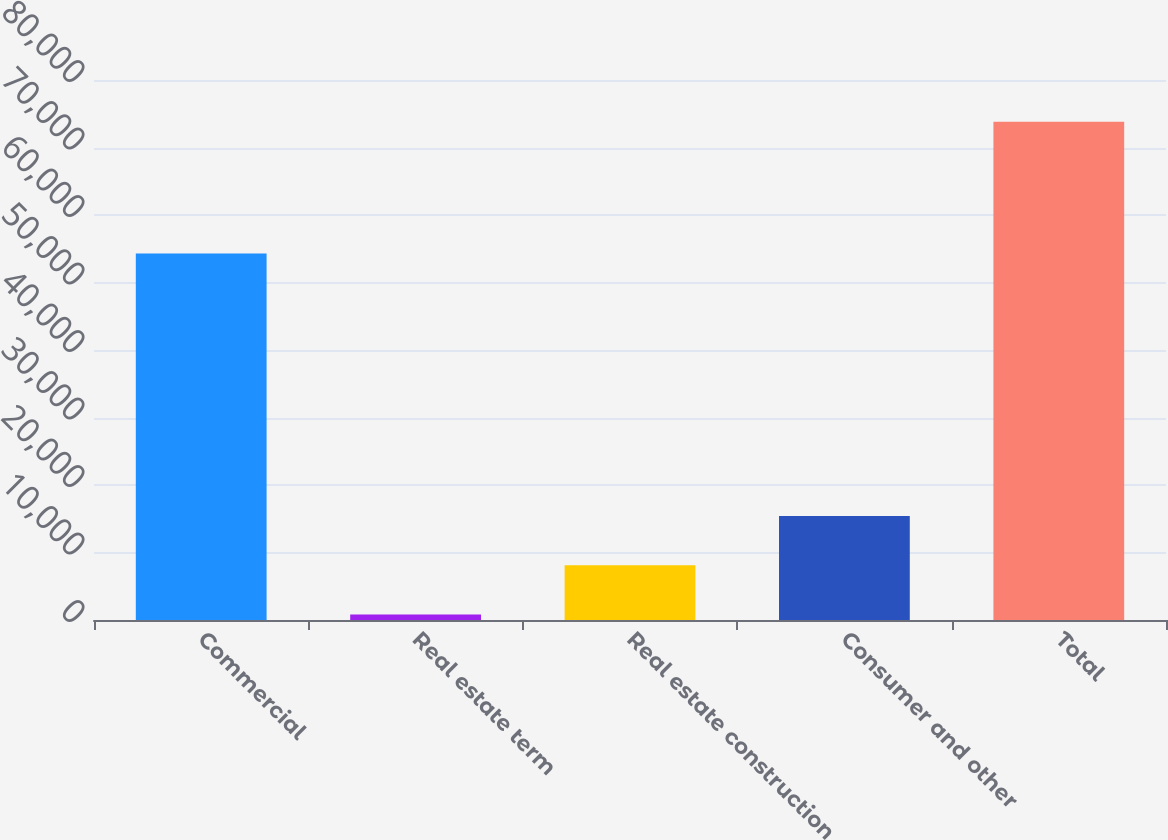Convert chart to OTSL. <chart><loc_0><loc_0><loc_500><loc_500><bar_chart><fcel>Commercial<fcel>Real estate term<fcel>Real estate construction<fcel>Consumer and other<fcel>Total<nl><fcel>54300<fcel>806<fcel>8105.4<fcel>15404.8<fcel>73800<nl></chart> 